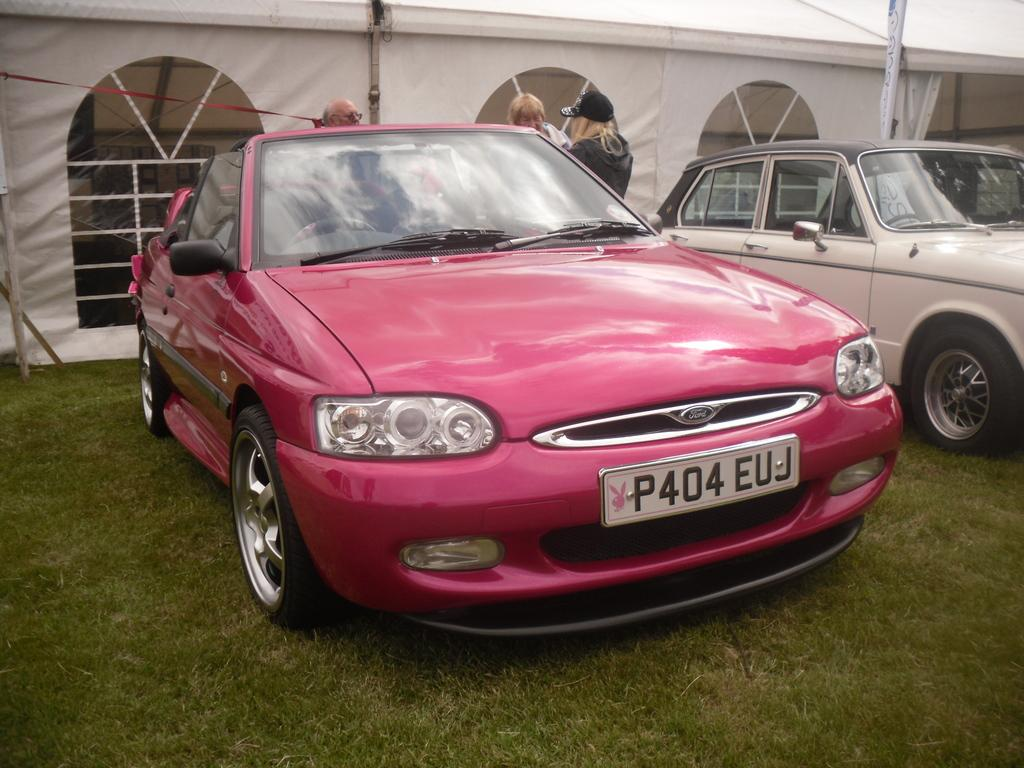<image>
Relay a brief, clear account of the picture shown. the front side of a magenta colored ford branded sedan parked on top of grass. 